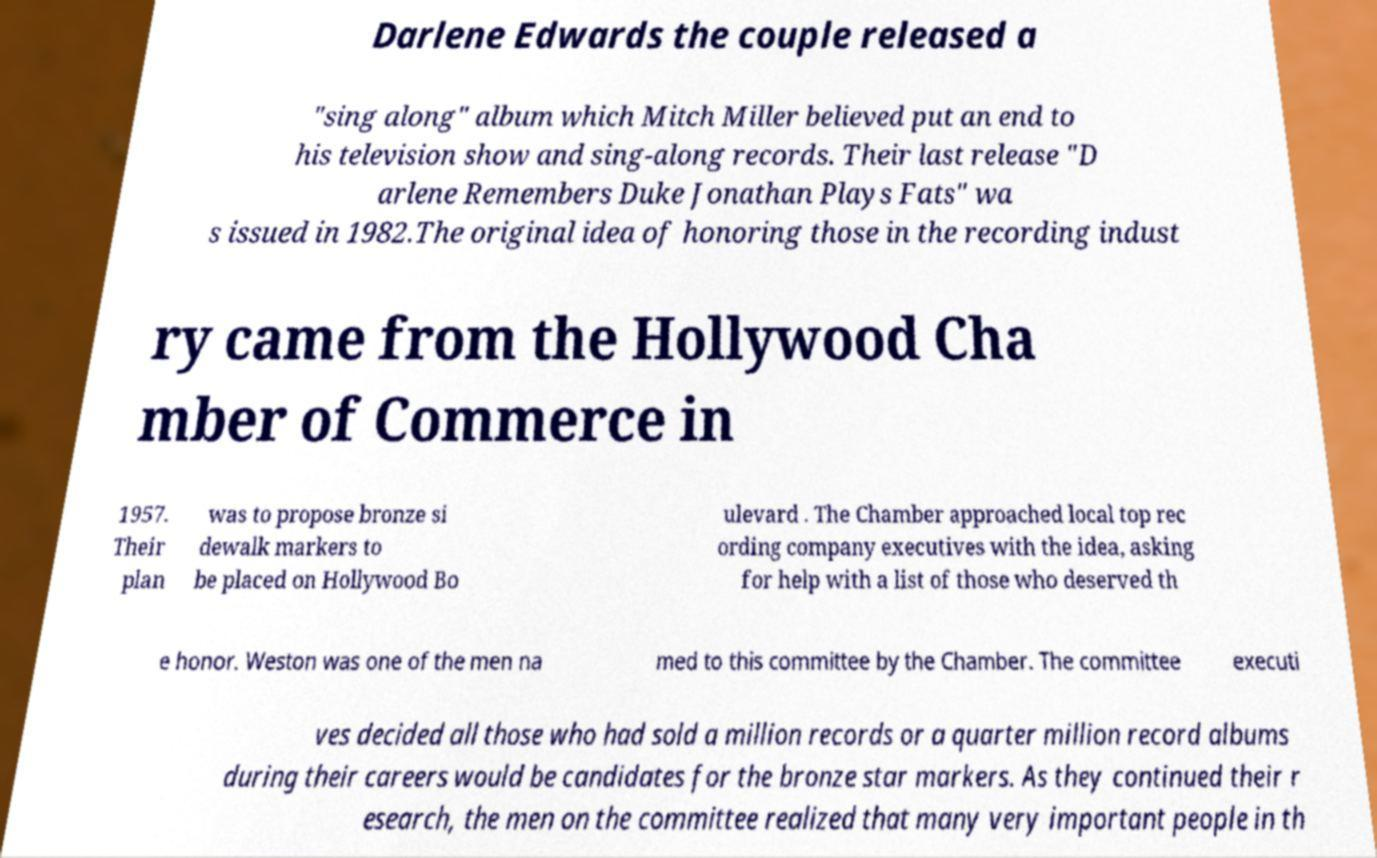Could you assist in decoding the text presented in this image and type it out clearly? Darlene Edwards the couple released a "sing along" album which Mitch Miller believed put an end to his television show and sing-along records. Their last release "D arlene Remembers Duke Jonathan Plays Fats" wa s issued in 1982.The original idea of honoring those in the recording indust ry came from the Hollywood Cha mber of Commerce in 1957. Their plan was to propose bronze si dewalk markers to be placed on Hollywood Bo ulevard . The Chamber approached local top rec ording company executives with the idea, asking for help with a list of those who deserved th e honor. Weston was one of the men na med to this committee by the Chamber. The committee executi ves decided all those who had sold a million records or a quarter million record albums during their careers would be candidates for the bronze star markers. As they continued their r esearch, the men on the committee realized that many very important people in th 